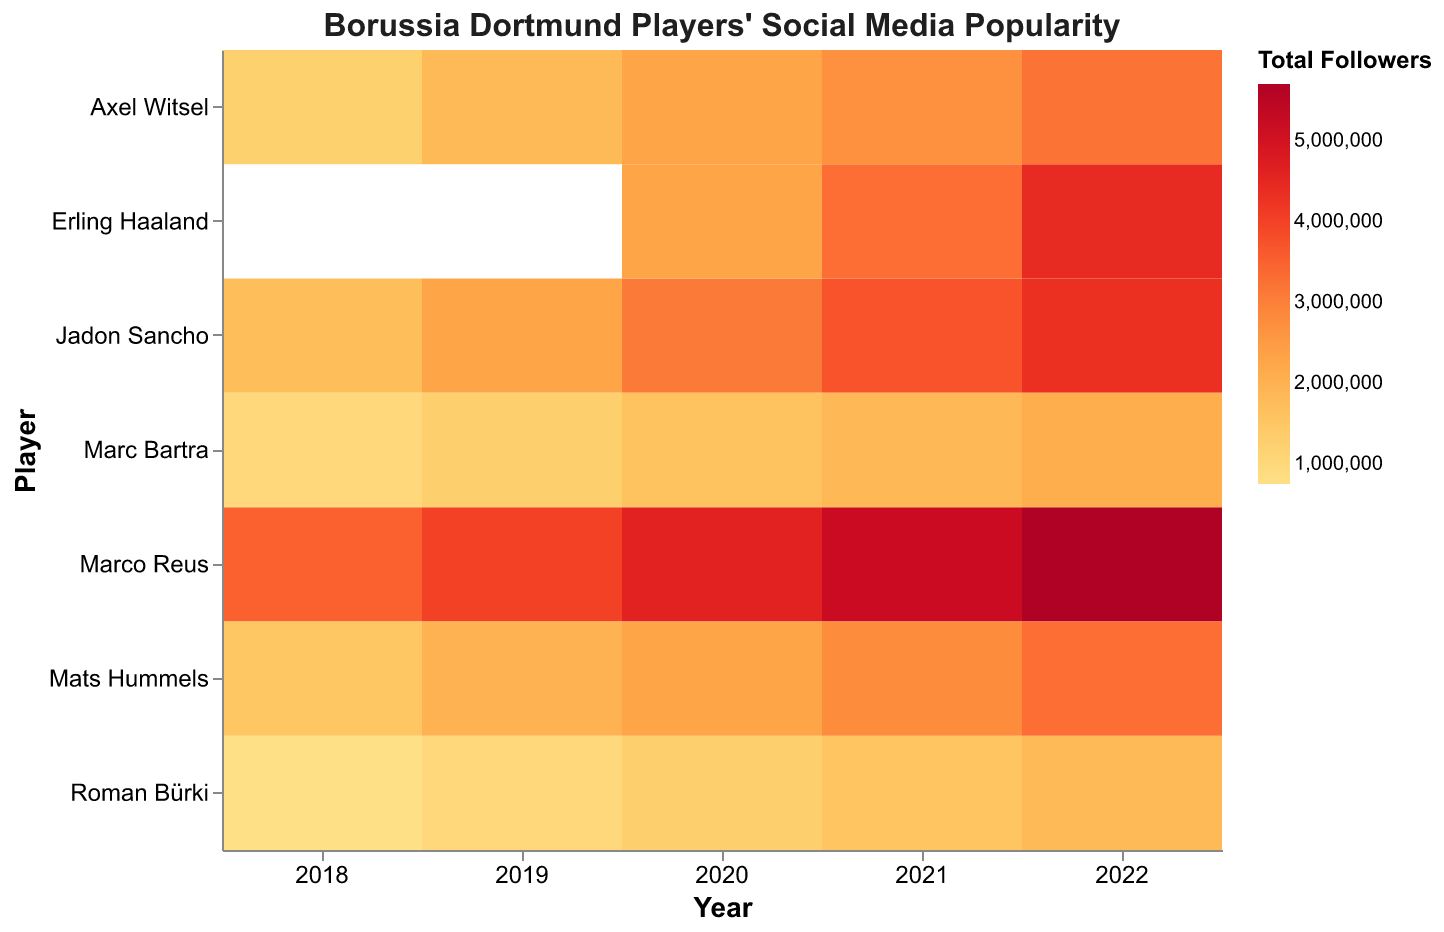What's the total number of Instagram followers for Marco Reus in 2022? You can find Marco Reus in the "Player" axis, then look at the value corresponding to the year 2022 within the "Instagram Followers" field.
Answer: 2,500,000 Which midfielder had the most total followers in 2022? Look at the "Midfielder" position values in 2022 on the x-axis, and compare the total followers values for each midfielder.
Answer: Jadon Sancho What is the difference in total followers between Erling Haaland and Marco Reus in 2021? Identify the total followers for both players in 2021 from the heatmap and subtract the total followers of Marco Reus from Erling Haaland. In 2021, Marco Reus had 5,200,000 total followers (2,300,000 Instagram + 1,800,000 Twitter + 1,100,000 Facebook) and Erling Haaland had 3,300,000 total followers (1,500,000 Instagram + 1,100,000 Twitter + 700,000 Facebook).
Answer: 1,900,000 How did Roman Bürki's popularity change on Instagram from 2018 to 2022? Find Roman Bürki's values under "Instagram Followers" for the years 2018 to 2022. Observe the trend over these years. He had 400,000 followers in 2018 and 800,000 in 2022.
Answer: It doubled Which player had the highest total followers in 2020? Look at all the players' total followers in the year 2020 and identify the highest value.
Answer: Marco Reus Which nationality has the player (or players) with the least total followers in 2018? Compare total followers among all nationalities in 2018. Identify the lowest value, which is 750,000 for Roman Bürki from Switzerland.
Answer: Switzerland What can you infer about the trend of Marco Reus's social media popularity over the 5 years? Look at Marco Reus's total followers from 2018 to 2022 and observe the trend. The visual shows an increase each year, moving from 3,500,000 in 2018 to 5,800,000 in 2022.
Answer: Increasing Compare Jadon Sancho and Axel Witsel's total followers in 2019. Who had more? Find each player's total followers in 2019: Jadon Sancho had 2,300,000 total followers (1,000,000 Instagram + 800,000 Twitter + 500,000 Facebook), Axel Witsel had 1,800,000 total followers (800,000 Instagram + 600,000 Twitter + 400,000 Facebook).
Answer: Jadon Sancho Which position generally had the highest total followers across the players and years? Compare the total followers across different positions (forward, midfielder, defender, goalkeeper) by the heatmap colors.
Answer: Forward 